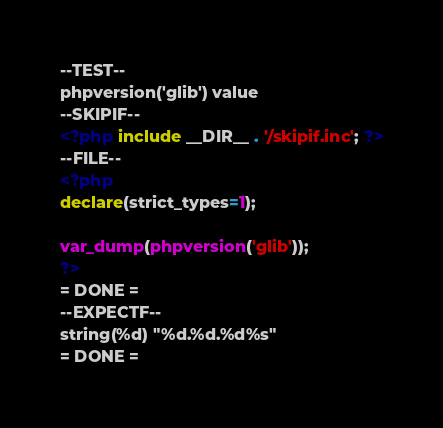<code> <loc_0><loc_0><loc_500><loc_500><_PHP_>--TEST--
phpversion('glib') value
--SKIPIF--
<?php include __DIR__ . '/skipif.inc'; ?>
--FILE--
<?php
declare(strict_types=1);

var_dump(phpversion('glib'));
?>
= DONE =
--EXPECTF--
string(%d) "%d.%d.%d%s"
= DONE =
</code> 